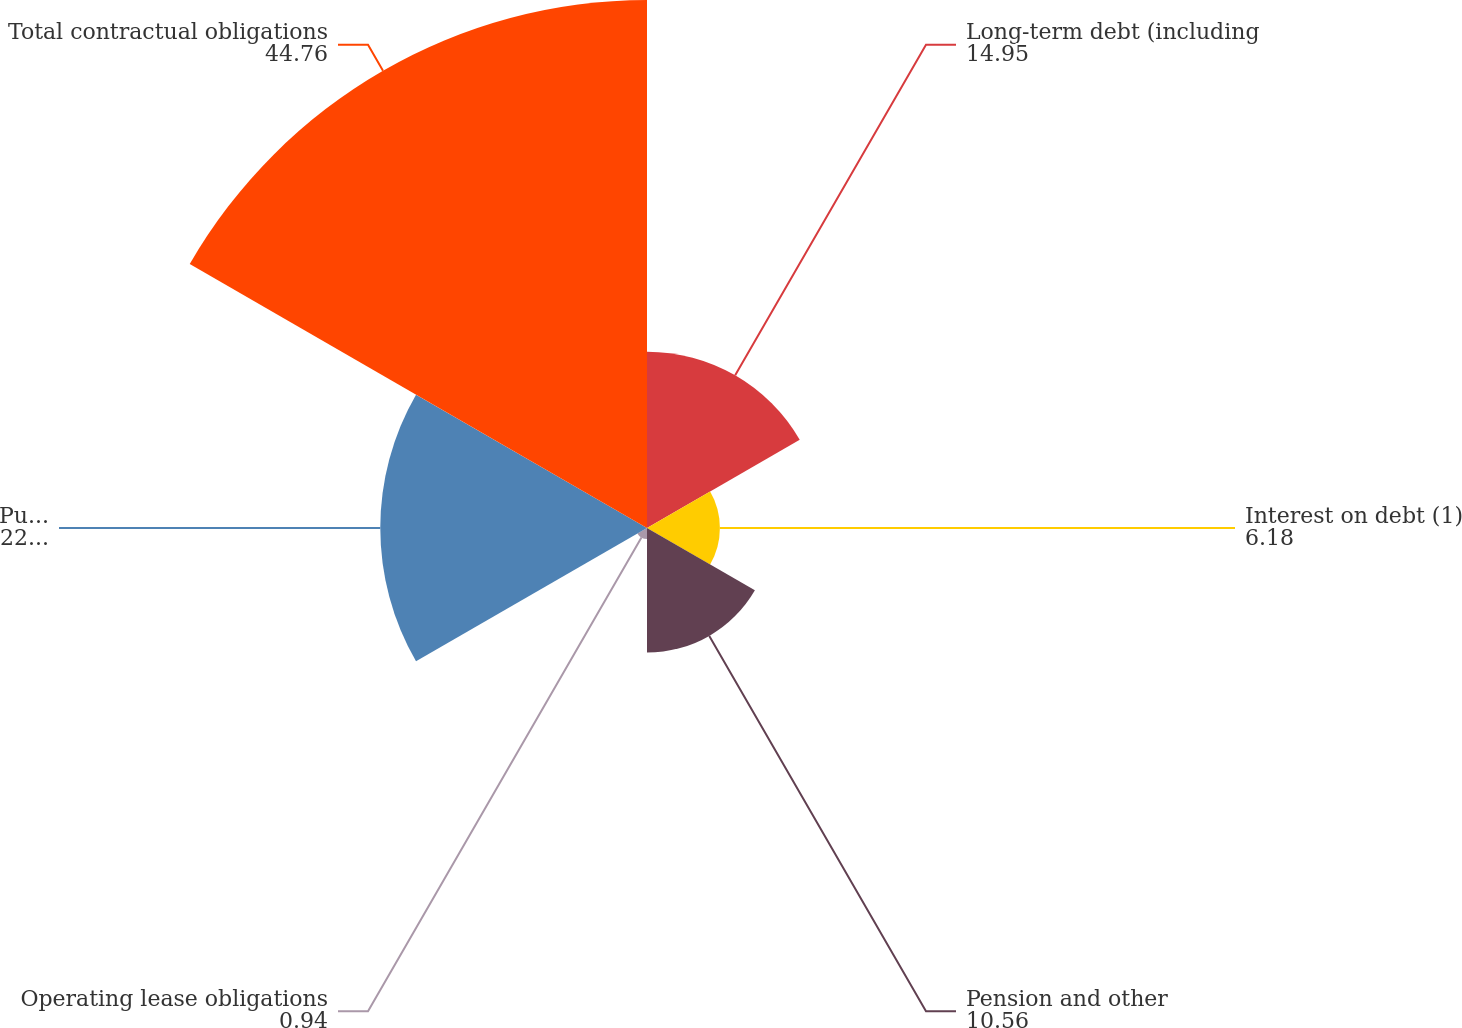Convert chart to OTSL. <chart><loc_0><loc_0><loc_500><loc_500><pie_chart><fcel>Long-term debt (including<fcel>Interest on debt (1)<fcel>Pension and other<fcel>Operating lease obligations<fcel>Purchase obligations not<fcel>Total contractual obligations<nl><fcel>14.95%<fcel>6.18%<fcel>10.56%<fcel>0.94%<fcel>22.61%<fcel>44.76%<nl></chart> 